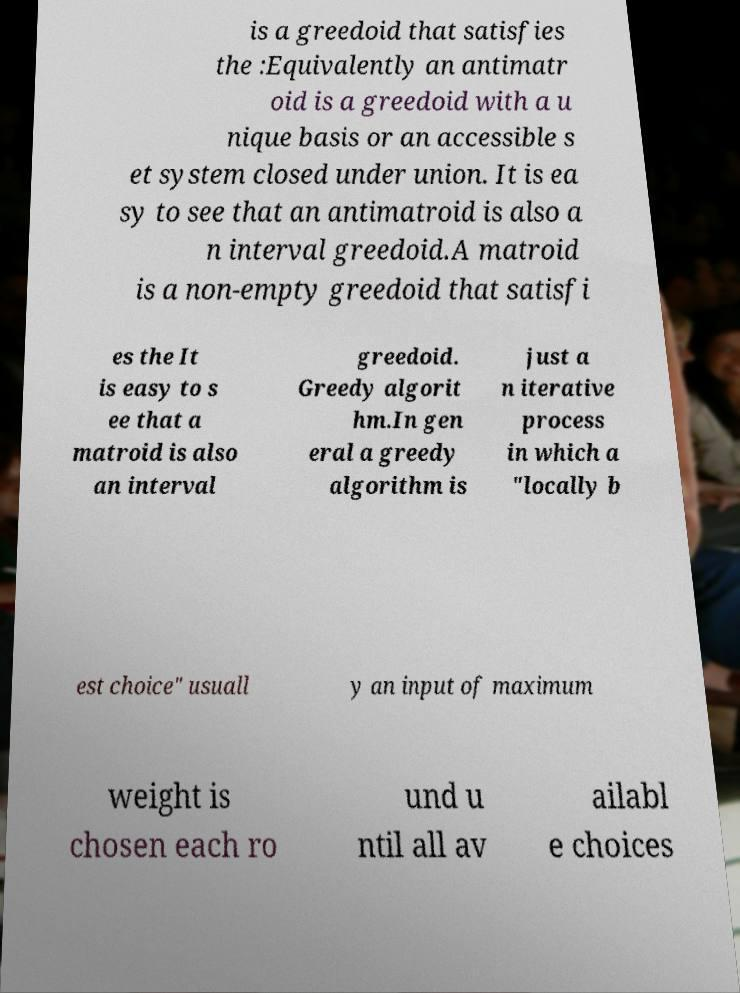What messages or text are displayed in this image? I need them in a readable, typed format. is a greedoid that satisfies the :Equivalently an antimatr oid is a greedoid with a u nique basis or an accessible s et system closed under union. It is ea sy to see that an antimatroid is also a n interval greedoid.A matroid is a non-empty greedoid that satisfi es the It is easy to s ee that a matroid is also an interval greedoid. Greedy algorit hm.In gen eral a greedy algorithm is just a n iterative process in which a "locally b est choice" usuall y an input of maximum weight is chosen each ro und u ntil all av ailabl e choices 